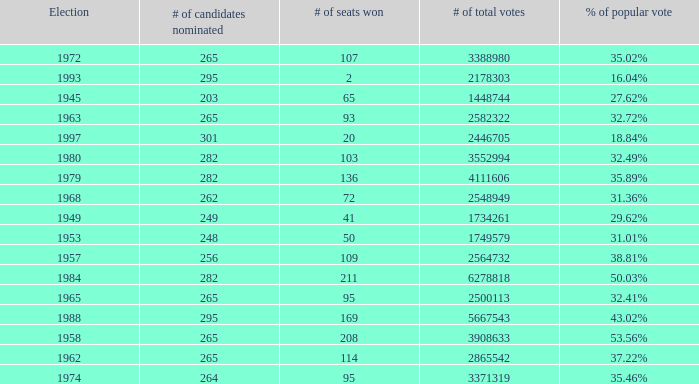How many times was the # of total votes 2582322? 1.0. 